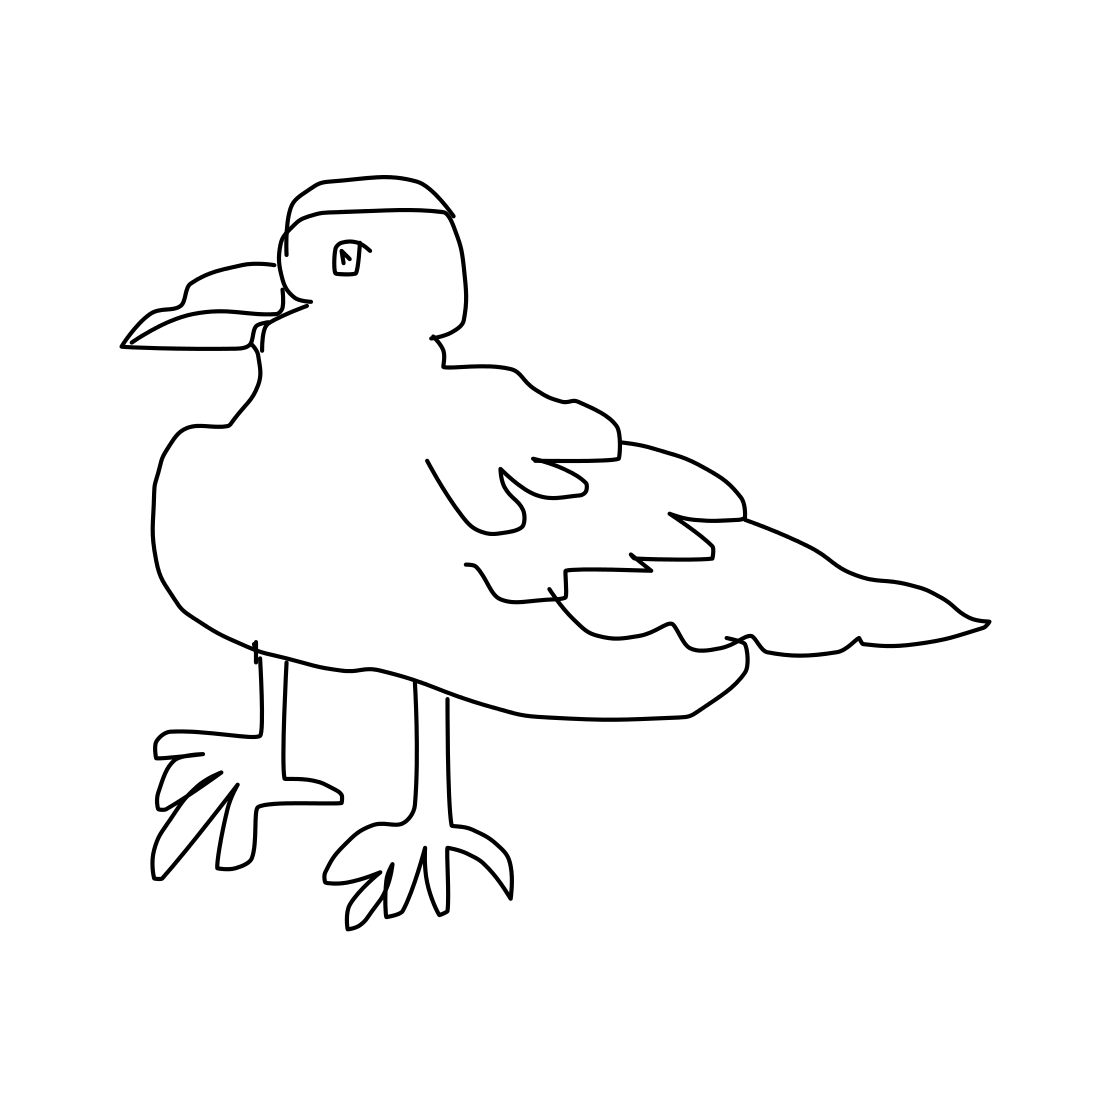In the scene, is a crab in it? There is no crab in the image. The image features a sketch of a bird standing upright, possibly a type of seabird based on its prominent beak and webbed feet. 